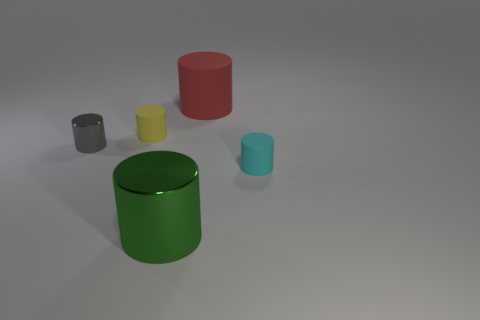Subtract all blue cylinders. Subtract all purple cubes. How many cylinders are left? 5 Add 4 big yellow rubber spheres. How many objects exist? 9 Subtract 0 brown cylinders. How many objects are left? 5 Subtract all large blue balls. Subtract all small objects. How many objects are left? 2 Add 2 large green cylinders. How many large green cylinders are left? 3 Add 3 tiny yellow cylinders. How many tiny yellow cylinders exist? 4 